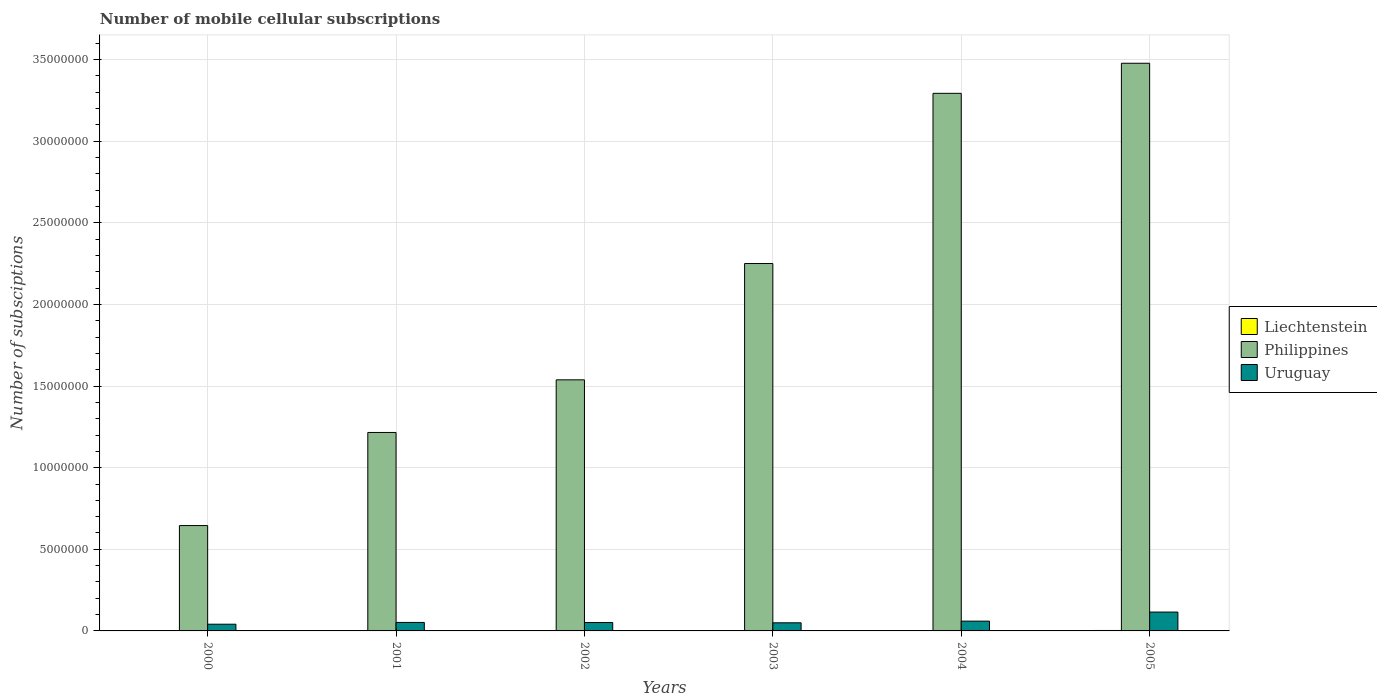Are the number of bars per tick equal to the number of legend labels?
Your answer should be very brief. Yes. Are the number of bars on each tick of the X-axis equal?
Provide a short and direct response. Yes. How many bars are there on the 3rd tick from the left?
Your response must be concise. 3. What is the label of the 6th group of bars from the left?
Keep it short and to the point. 2005. In how many cases, is the number of bars for a given year not equal to the number of legend labels?
Give a very brief answer. 0. What is the number of mobile cellular subscriptions in Uruguay in 2005?
Give a very brief answer. 1.15e+06. Across all years, what is the maximum number of mobile cellular subscriptions in Uruguay?
Give a very brief answer. 1.15e+06. Across all years, what is the minimum number of mobile cellular subscriptions in Uruguay?
Provide a succinct answer. 4.11e+05. In which year was the number of mobile cellular subscriptions in Liechtenstein minimum?
Give a very brief answer. 2000. What is the total number of mobile cellular subscriptions in Uruguay in the graph?
Offer a terse response. 3.70e+06. What is the difference between the number of mobile cellular subscriptions in Liechtenstein in 2000 and that in 2004?
Your answer should be very brief. -1.55e+04. What is the difference between the number of mobile cellular subscriptions in Philippines in 2000 and the number of mobile cellular subscriptions in Uruguay in 2004?
Make the answer very short. 5.85e+06. What is the average number of mobile cellular subscriptions in Uruguay per year?
Keep it short and to the point. 6.16e+05. In the year 2002, what is the difference between the number of mobile cellular subscriptions in Philippines and number of mobile cellular subscriptions in Liechtenstein?
Your response must be concise. 1.54e+07. What is the ratio of the number of mobile cellular subscriptions in Uruguay in 2001 to that in 2005?
Provide a short and direct response. 0.45. Is the difference between the number of mobile cellular subscriptions in Philippines in 2001 and 2004 greater than the difference between the number of mobile cellular subscriptions in Liechtenstein in 2001 and 2004?
Provide a short and direct response. No. What is the difference between the highest and the second highest number of mobile cellular subscriptions in Uruguay?
Provide a succinct answer. 5.55e+05. What is the difference between the highest and the lowest number of mobile cellular subscriptions in Uruguay?
Your answer should be very brief. 7.44e+05. In how many years, is the number of mobile cellular subscriptions in Uruguay greater than the average number of mobile cellular subscriptions in Uruguay taken over all years?
Your response must be concise. 1. What does the 3rd bar from the right in 2000 represents?
Keep it short and to the point. Liechtenstein. Is it the case that in every year, the sum of the number of mobile cellular subscriptions in Philippines and number of mobile cellular subscriptions in Liechtenstein is greater than the number of mobile cellular subscriptions in Uruguay?
Make the answer very short. Yes. How many bars are there?
Keep it short and to the point. 18. How many years are there in the graph?
Keep it short and to the point. 6. What is the difference between two consecutive major ticks on the Y-axis?
Provide a succinct answer. 5.00e+06. Does the graph contain any zero values?
Offer a terse response. No. How are the legend labels stacked?
Offer a terse response. Vertical. What is the title of the graph?
Offer a terse response. Number of mobile cellular subscriptions. Does "Sao Tome and Principe" appear as one of the legend labels in the graph?
Your answer should be compact. No. What is the label or title of the Y-axis?
Your answer should be compact. Number of subsciptions. What is the Number of subsciptions in Philippines in 2000?
Give a very brief answer. 6.45e+06. What is the Number of subsciptions in Uruguay in 2000?
Make the answer very short. 4.11e+05. What is the Number of subsciptions of Liechtenstein in 2001?
Make the answer very short. 1.10e+04. What is the Number of subsciptions of Philippines in 2001?
Provide a succinct answer. 1.22e+07. What is the Number of subsciptions in Uruguay in 2001?
Provide a short and direct response. 5.20e+05. What is the Number of subsciptions in Liechtenstein in 2002?
Provide a succinct answer. 1.14e+04. What is the Number of subsciptions of Philippines in 2002?
Ensure brevity in your answer.  1.54e+07. What is the Number of subsciptions of Uruguay in 2002?
Provide a short and direct response. 5.14e+05. What is the Number of subsciptions of Liechtenstein in 2003?
Your answer should be compact. 2.50e+04. What is the Number of subsciptions in Philippines in 2003?
Your answer should be very brief. 2.25e+07. What is the Number of subsciptions in Uruguay in 2003?
Your answer should be compact. 4.98e+05. What is the Number of subsciptions in Liechtenstein in 2004?
Provide a succinct answer. 2.55e+04. What is the Number of subsciptions in Philippines in 2004?
Offer a very short reply. 3.29e+07. What is the Number of subsciptions of Uruguay in 2004?
Make the answer very short. 6.00e+05. What is the Number of subsciptions of Liechtenstein in 2005?
Keep it short and to the point. 2.75e+04. What is the Number of subsciptions of Philippines in 2005?
Give a very brief answer. 3.48e+07. What is the Number of subsciptions of Uruguay in 2005?
Provide a short and direct response. 1.15e+06. Across all years, what is the maximum Number of subsciptions in Liechtenstein?
Provide a succinct answer. 2.75e+04. Across all years, what is the maximum Number of subsciptions in Philippines?
Offer a terse response. 3.48e+07. Across all years, what is the maximum Number of subsciptions in Uruguay?
Ensure brevity in your answer.  1.15e+06. Across all years, what is the minimum Number of subsciptions of Liechtenstein?
Your response must be concise. 10000. Across all years, what is the minimum Number of subsciptions of Philippines?
Your answer should be compact. 6.45e+06. Across all years, what is the minimum Number of subsciptions in Uruguay?
Provide a short and direct response. 4.11e+05. What is the total Number of subsciptions of Liechtenstein in the graph?
Your answer should be very brief. 1.10e+05. What is the total Number of subsciptions of Philippines in the graph?
Offer a terse response. 1.24e+08. What is the total Number of subsciptions of Uruguay in the graph?
Make the answer very short. 3.70e+06. What is the difference between the Number of subsciptions in Liechtenstein in 2000 and that in 2001?
Give a very brief answer. -1000. What is the difference between the Number of subsciptions of Philippines in 2000 and that in 2001?
Make the answer very short. -5.70e+06. What is the difference between the Number of subsciptions of Uruguay in 2000 and that in 2001?
Provide a short and direct response. -1.09e+05. What is the difference between the Number of subsciptions in Liechtenstein in 2000 and that in 2002?
Make the answer very short. -1402. What is the difference between the Number of subsciptions of Philippines in 2000 and that in 2002?
Give a very brief answer. -8.93e+06. What is the difference between the Number of subsciptions in Uruguay in 2000 and that in 2002?
Offer a very short reply. -1.03e+05. What is the difference between the Number of subsciptions in Liechtenstein in 2000 and that in 2003?
Make the answer very short. -1.50e+04. What is the difference between the Number of subsciptions of Philippines in 2000 and that in 2003?
Your response must be concise. -1.61e+07. What is the difference between the Number of subsciptions of Uruguay in 2000 and that in 2003?
Your response must be concise. -8.67e+04. What is the difference between the Number of subsciptions in Liechtenstein in 2000 and that in 2004?
Provide a succinct answer. -1.55e+04. What is the difference between the Number of subsciptions in Philippines in 2000 and that in 2004?
Give a very brief answer. -2.65e+07. What is the difference between the Number of subsciptions of Uruguay in 2000 and that in 2004?
Your answer should be very brief. -1.89e+05. What is the difference between the Number of subsciptions of Liechtenstein in 2000 and that in 2005?
Provide a short and direct response. -1.75e+04. What is the difference between the Number of subsciptions of Philippines in 2000 and that in 2005?
Keep it short and to the point. -2.83e+07. What is the difference between the Number of subsciptions in Uruguay in 2000 and that in 2005?
Provide a succinct answer. -7.44e+05. What is the difference between the Number of subsciptions in Liechtenstein in 2001 and that in 2002?
Ensure brevity in your answer.  -402. What is the difference between the Number of subsciptions of Philippines in 2001 and that in 2002?
Keep it short and to the point. -3.22e+06. What is the difference between the Number of subsciptions of Uruguay in 2001 and that in 2002?
Ensure brevity in your answer.  6463. What is the difference between the Number of subsciptions in Liechtenstein in 2001 and that in 2003?
Offer a terse response. -1.40e+04. What is the difference between the Number of subsciptions of Philippines in 2001 and that in 2003?
Your answer should be very brief. -1.04e+07. What is the difference between the Number of subsciptions in Uruguay in 2001 and that in 2003?
Provide a succinct answer. 2.25e+04. What is the difference between the Number of subsciptions in Liechtenstein in 2001 and that in 2004?
Your response must be concise. -1.45e+04. What is the difference between the Number of subsciptions of Philippines in 2001 and that in 2004?
Your answer should be compact. -2.08e+07. What is the difference between the Number of subsciptions in Uruguay in 2001 and that in 2004?
Your answer should be very brief. -7.98e+04. What is the difference between the Number of subsciptions of Liechtenstein in 2001 and that in 2005?
Offer a very short reply. -1.65e+04. What is the difference between the Number of subsciptions of Philippines in 2001 and that in 2005?
Give a very brief answer. -2.26e+07. What is the difference between the Number of subsciptions of Uruguay in 2001 and that in 2005?
Offer a very short reply. -6.35e+05. What is the difference between the Number of subsciptions of Liechtenstein in 2002 and that in 2003?
Ensure brevity in your answer.  -1.36e+04. What is the difference between the Number of subsciptions in Philippines in 2002 and that in 2003?
Ensure brevity in your answer.  -7.13e+06. What is the difference between the Number of subsciptions in Uruguay in 2002 and that in 2003?
Provide a succinct answer. 1.60e+04. What is the difference between the Number of subsciptions in Liechtenstein in 2002 and that in 2004?
Keep it short and to the point. -1.41e+04. What is the difference between the Number of subsciptions of Philippines in 2002 and that in 2004?
Offer a terse response. -1.76e+07. What is the difference between the Number of subsciptions of Uruguay in 2002 and that in 2004?
Your answer should be compact. -8.62e+04. What is the difference between the Number of subsciptions in Liechtenstein in 2002 and that in 2005?
Make the answer very short. -1.61e+04. What is the difference between the Number of subsciptions in Philippines in 2002 and that in 2005?
Make the answer very short. -1.94e+07. What is the difference between the Number of subsciptions in Uruguay in 2002 and that in 2005?
Provide a succinct answer. -6.41e+05. What is the difference between the Number of subsciptions of Liechtenstein in 2003 and that in 2004?
Provide a short and direct response. -500. What is the difference between the Number of subsciptions of Philippines in 2003 and that in 2004?
Make the answer very short. -1.04e+07. What is the difference between the Number of subsciptions of Uruguay in 2003 and that in 2004?
Provide a short and direct response. -1.02e+05. What is the difference between the Number of subsciptions in Liechtenstein in 2003 and that in 2005?
Your response must be concise. -2503. What is the difference between the Number of subsciptions of Philippines in 2003 and that in 2005?
Your answer should be compact. -1.23e+07. What is the difference between the Number of subsciptions in Uruguay in 2003 and that in 2005?
Your response must be concise. -6.57e+05. What is the difference between the Number of subsciptions of Liechtenstein in 2004 and that in 2005?
Give a very brief answer. -2003. What is the difference between the Number of subsciptions of Philippines in 2004 and that in 2005?
Ensure brevity in your answer.  -1.84e+06. What is the difference between the Number of subsciptions in Uruguay in 2004 and that in 2005?
Make the answer very short. -5.55e+05. What is the difference between the Number of subsciptions of Liechtenstein in 2000 and the Number of subsciptions of Philippines in 2001?
Offer a very short reply. -1.21e+07. What is the difference between the Number of subsciptions in Liechtenstein in 2000 and the Number of subsciptions in Uruguay in 2001?
Make the answer very short. -5.10e+05. What is the difference between the Number of subsciptions in Philippines in 2000 and the Number of subsciptions in Uruguay in 2001?
Make the answer very short. 5.93e+06. What is the difference between the Number of subsciptions in Liechtenstein in 2000 and the Number of subsciptions in Philippines in 2002?
Offer a terse response. -1.54e+07. What is the difference between the Number of subsciptions in Liechtenstein in 2000 and the Number of subsciptions in Uruguay in 2002?
Your answer should be very brief. -5.04e+05. What is the difference between the Number of subsciptions of Philippines in 2000 and the Number of subsciptions of Uruguay in 2002?
Ensure brevity in your answer.  5.94e+06. What is the difference between the Number of subsciptions of Liechtenstein in 2000 and the Number of subsciptions of Philippines in 2003?
Offer a terse response. -2.25e+07. What is the difference between the Number of subsciptions of Liechtenstein in 2000 and the Number of subsciptions of Uruguay in 2003?
Provide a succinct answer. -4.88e+05. What is the difference between the Number of subsciptions in Philippines in 2000 and the Number of subsciptions in Uruguay in 2003?
Keep it short and to the point. 5.96e+06. What is the difference between the Number of subsciptions of Liechtenstein in 2000 and the Number of subsciptions of Philippines in 2004?
Your answer should be compact. -3.29e+07. What is the difference between the Number of subsciptions in Liechtenstein in 2000 and the Number of subsciptions in Uruguay in 2004?
Ensure brevity in your answer.  -5.90e+05. What is the difference between the Number of subsciptions in Philippines in 2000 and the Number of subsciptions in Uruguay in 2004?
Keep it short and to the point. 5.85e+06. What is the difference between the Number of subsciptions in Liechtenstein in 2000 and the Number of subsciptions in Philippines in 2005?
Ensure brevity in your answer.  -3.48e+07. What is the difference between the Number of subsciptions of Liechtenstein in 2000 and the Number of subsciptions of Uruguay in 2005?
Offer a terse response. -1.14e+06. What is the difference between the Number of subsciptions of Philippines in 2000 and the Number of subsciptions of Uruguay in 2005?
Your answer should be compact. 5.30e+06. What is the difference between the Number of subsciptions in Liechtenstein in 2001 and the Number of subsciptions in Philippines in 2002?
Your answer should be compact. -1.54e+07. What is the difference between the Number of subsciptions in Liechtenstein in 2001 and the Number of subsciptions in Uruguay in 2002?
Your answer should be compact. -5.03e+05. What is the difference between the Number of subsciptions of Philippines in 2001 and the Number of subsciptions of Uruguay in 2002?
Your answer should be very brief. 1.16e+07. What is the difference between the Number of subsciptions of Liechtenstein in 2001 and the Number of subsciptions of Philippines in 2003?
Provide a short and direct response. -2.25e+07. What is the difference between the Number of subsciptions of Liechtenstein in 2001 and the Number of subsciptions of Uruguay in 2003?
Offer a terse response. -4.87e+05. What is the difference between the Number of subsciptions in Philippines in 2001 and the Number of subsciptions in Uruguay in 2003?
Ensure brevity in your answer.  1.17e+07. What is the difference between the Number of subsciptions of Liechtenstein in 2001 and the Number of subsciptions of Philippines in 2004?
Provide a succinct answer. -3.29e+07. What is the difference between the Number of subsciptions of Liechtenstein in 2001 and the Number of subsciptions of Uruguay in 2004?
Offer a very short reply. -5.89e+05. What is the difference between the Number of subsciptions of Philippines in 2001 and the Number of subsciptions of Uruguay in 2004?
Your response must be concise. 1.16e+07. What is the difference between the Number of subsciptions of Liechtenstein in 2001 and the Number of subsciptions of Philippines in 2005?
Make the answer very short. -3.48e+07. What is the difference between the Number of subsciptions in Liechtenstein in 2001 and the Number of subsciptions in Uruguay in 2005?
Offer a very short reply. -1.14e+06. What is the difference between the Number of subsciptions of Philippines in 2001 and the Number of subsciptions of Uruguay in 2005?
Your answer should be very brief. 1.10e+07. What is the difference between the Number of subsciptions in Liechtenstein in 2002 and the Number of subsciptions in Philippines in 2003?
Ensure brevity in your answer.  -2.25e+07. What is the difference between the Number of subsciptions of Liechtenstein in 2002 and the Number of subsciptions of Uruguay in 2003?
Make the answer very short. -4.86e+05. What is the difference between the Number of subsciptions in Philippines in 2002 and the Number of subsciptions in Uruguay in 2003?
Give a very brief answer. 1.49e+07. What is the difference between the Number of subsciptions in Liechtenstein in 2002 and the Number of subsciptions in Philippines in 2004?
Your answer should be very brief. -3.29e+07. What is the difference between the Number of subsciptions in Liechtenstein in 2002 and the Number of subsciptions in Uruguay in 2004?
Give a very brief answer. -5.88e+05. What is the difference between the Number of subsciptions in Philippines in 2002 and the Number of subsciptions in Uruguay in 2004?
Offer a very short reply. 1.48e+07. What is the difference between the Number of subsciptions of Liechtenstein in 2002 and the Number of subsciptions of Philippines in 2005?
Offer a terse response. -3.48e+07. What is the difference between the Number of subsciptions in Liechtenstein in 2002 and the Number of subsciptions in Uruguay in 2005?
Offer a terse response. -1.14e+06. What is the difference between the Number of subsciptions in Philippines in 2002 and the Number of subsciptions in Uruguay in 2005?
Offer a terse response. 1.42e+07. What is the difference between the Number of subsciptions of Liechtenstein in 2003 and the Number of subsciptions of Philippines in 2004?
Provide a short and direct response. -3.29e+07. What is the difference between the Number of subsciptions of Liechtenstein in 2003 and the Number of subsciptions of Uruguay in 2004?
Give a very brief answer. -5.75e+05. What is the difference between the Number of subsciptions of Philippines in 2003 and the Number of subsciptions of Uruguay in 2004?
Offer a very short reply. 2.19e+07. What is the difference between the Number of subsciptions in Liechtenstein in 2003 and the Number of subsciptions in Philippines in 2005?
Ensure brevity in your answer.  -3.48e+07. What is the difference between the Number of subsciptions in Liechtenstein in 2003 and the Number of subsciptions in Uruguay in 2005?
Your answer should be very brief. -1.13e+06. What is the difference between the Number of subsciptions of Philippines in 2003 and the Number of subsciptions of Uruguay in 2005?
Keep it short and to the point. 2.14e+07. What is the difference between the Number of subsciptions in Liechtenstein in 2004 and the Number of subsciptions in Philippines in 2005?
Offer a terse response. -3.48e+07. What is the difference between the Number of subsciptions of Liechtenstein in 2004 and the Number of subsciptions of Uruguay in 2005?
Give a very brief answer. -1.13e+06. What is the difference between the Number of subsciptions of Philippines in 2004 and the Number of subsciptions of Uruguay in 2005?
Keep it short and to the point. 3.18e+07. What is the average Number of subsciptions in Liechtenstein per year?
Ensure brevity in your answer.  1.84e+04. What is the average Number of subsciptions of Philippines per year?
Keep it short and to the point. 2.07e+07. What is the average Number of subsciptions of Uruguay per year?
Give a very brief answer. 6.16e+05. In the year 2000, what is the difference between the Number of subsciptions of Liechtenstein and Number of subsciptions of Philippines?
Make the answer very short. -6.44e+06. In the year 2000, what is the difference between the Number of subsciptions of Liechtenstein and Number of subsciptions of Uruguay?
Make the answer very short. -4.01e+05. In the year 2000, what is the difference between the Number of subsciptions of Philippines and Number of subsciptions of Uruguay?
Provide a short and direct response. 6.04e+06. In the year 2001, what is the difference between the Number of subsciptions in Liechtenstein and Number of subsciptions in Philippines?
Provide a short and direct response. -1.21e+07. In the year 2001, what is the difference between the Number of subsciptions in Liechtenstein and Number of subsciptions in Uruguay?
Offer a terse response. -5.09e+05. In the year 2001, what is the difference between the Number of subsciptions in Philippines and Number of subsciptions in Uruguay?
Keep it short and to the point. 1.16e+07. In the year 2002, what is the difference between the Number of subsciptions in Liechtenstein and Number of subsciptions in Philippines?
Your answer should be compact. -1.54e+07. In the year 2002, what is the difference between the Number of subsciptions of Liechtenstein and Number of subsciptions of Uruguay?
Provide a short and direct response. -5.02e+05. In the year 2002, what is the difference between the Number of subsciptions in Philippines and Number of subsciptions in Uruguay?
Your answer should be compact. 1.49e+07. In the year 2003, what is the difference between the Number of subsciptions in Liechtenstein and Number of subsciptions in Philippines?
Give a very brief answer. -2.25e+07. In the year 2003, what is the difference between the Number of subsciptions in Liechtenstein and Number of subsciptions in Uruguay?
Give a very brief answer. -4.73e+05. In the year 2003, what is the difference between the Number of subsciptions of Philippines and Number of subsciptions of Uruguay?
Offer a very short reply. 2.20e+07. In the year 2004, what is the difference between the Number of subsciptions in Liechtenstein and Number of subsciptions in Philippines?
Ensure brevity in your answer.  -3.29e+07. In the year 2004, what is the difference between the Number of subsciptions of Liechtenstein and Number of subsciptions of Uruguay?
Offer a terse response. -5.74e+05. In the year 2004, what is the difference between the Number of subsciptions in Philippines and Number of subsciptions in Uruguay?
Make the answer very short. 3.23e+07. In the year 2005, what is the difference between the Number of subsciptions in Liechtenstein and Number of subsciptions in Philippines?
Offer a terse response. -3.48e+07. In the year 2005, what is the difference between the Number of subsciptions of Liechtenstein and Number of subsciptions of Uruguay?
Ensure brevity in your answer.  -1.13e+06. In the year 2005, what is the difference between the Number of subsciptions in Philippines and Number of subsciptions in Uruguay?
Your response must be concise. 3.36e+07. What is the ratio of the Number of subsciptions of Liechtenstein in 2000 to that in 2001?
Your response must be concise. 0.91. What is the ratio of the Number of subsciptions in Philippines in 2000 to that in 2001?
Make the answer very short. 0.53. What is the ratio of the Number of subsciptions of Uruguay in 2000 to that in 2001?
Give a very brief answer. 0.79. What is the ratio of the Number of subsciptions of Liechtenstein in 2000 to that in 2002?
Ensure brevity in your answer.  0.88. What is the ratio of the Number of subsciptions in Philippines in 2000 to that in 2002?
Make the answer very short. 0.42. What is the ratio of the Number of subsciptions of Uruguay in 2000 to that in 2002?
Give a very brief answer. 0.8. What is the ratio of the Number of subsciptions in Liechtenstein in 2000 to that in 2003?
Your answer should be compact. 0.4. What is the ratio of the Number of subsciptions of Philippines in 2000 to that in 2003?
Your response must be concise. 0.29. What is the ratio of the Number of subsciptions in Uruguay in 2000 to that in 2003?
Make the answer very short. 0.83. What is the ratio of the Number of subsciptions of Liechtenstein in 2000 to that in 2004?
Provide a succinct answer. 0.39. What is the ratio of the Number of subsciptions in Philippines in 2000 to that in 2004?
Your answer should be compact. 0.2. What is the ratio of the Number of subsciptions in Uruguay in 2000 to that in 2004?
Your answer should be compact. 0.68. What is the ratio of the Number of subsciptions in Liechtenstein in 2000 to that in 2005?
Make the answer very short. 0.36. What is the ratio of the Number of subsciptions of Philippines in 2000 to that in 2005?
Offer a very short reply. 0.19. What is the ratio of the Number of subsciptions in Uruguay in 2000 to that in 2005?
Give a very brief answer. 0.36. What is the ratio of the Number of subsciptions in Liechtenstein in 2001 to that in 2002?
Give a very brief answer. 0.96. What is the ratio of the Number of subsciptions in Philippines in 2001 to that in 2002?
Your response must be concise. 0.79. What is the ratio of the Number of subsciptions in Uruguay in 2001 to that in 2002?
Give a very brief answer. 1.01. What is the ratio of the Number of subsciptions of Liechtenstein in 2001 to that in 2003?
Offer a very short reply. 0.44. What is the ratio of the Number of subsciptions of Philippines in 2001 to that in 2003?
Offer a very short reply. 0.54. What is the ratio of the Number of subsciptions of Uruguay in 2001 to that in 2003?
Your answer should be very brief. 1.05. What is the ratio of the Number of subsciptions of Liechtenstein in 2001 to that in 2004?
Offer a very short reply. 0.43. What is the ratio of the Number of subsciptions in Philippines in 2001 to that in 2004?
Provide a succinct answer. 0.37. What is the ratio of the Number of subsciptions of Uruguay in 2001 to that in 2004?
Keep it short and to the point. 0.87. What is the ratio of the Number of subsciptions of Philippines in 2001 to that in 2005?
Your response must be concise. 0.35. What is the ratio of the Number of subsciptions of Uruguay in 2001 to that in 2005?
Keep it short and to the point. 0.45. What is the ratio of the Number of subsciptions of Liechtenstein in 2002 to that in 2003?
Your answer should be compact. 0.46. What is the ratio of the Number of subsciptions of Philippines in 2002 to that in 2003?
Offer a very short reply. 0.68. What is the ratio of the Number of subsciptions of Uruguay in 2002 to that in 2003?
Keep it short and to the point. 1.03. What is the ratio of the Number of subsciptions in Liechtenstein in 2002 to that in 2004?
Your response must be concise. 0.45. What is the ratio of the Number of subsciptions of Philippines in 2002 to that in 2004?
Give a very brief answer. 0.47. What is the ratio of the Number of subsciptions of Uruguay in 2002 to that in 2004?
Your answer should be compact. 0.86. What is the ratio of the Number of subsciptions in Liechtenstein in 2002 to that in 2005?
Your answer should be compact. 0.41. What is the ratio of the Number of subsciptions in Philippines in 2002 to that in 2005?
Offer a terse response. 0.44. What is the ratio of the Number of subsciptions in Uruguay in 2002 to that in 2005?
Your response must be concise. 0.44. What is the ratio of the Number of subsciptions of Liechtenstein in 2003 to that in 2004?
Offer a terse response. 0.98. What is the ratio of the Number of subsciptions in Philippines in 2003 to that in 2004?
Keep it short and to the point. 0.68. What is the ratio of the Number of subsciptions of Uruguay in 2003 to that in 2004?
Your response must be concise. 0.83. What is the ratio of the Number of subsciptions in Liechtenstein in 2003 to that in 2005?
Provide a succinct answer. 0.91. What is the ratio of the Number of subsciptions in Philippines in 2003 to that in 2005?
Offer a very short reply. 0.65. What is the ratio of the Number of subsciptions in Uruguay in 2003 to that in 2005?
Your answer should be compact. 0.43. What is the ratio of the Number of subsciptions of Liechtenstein in 2004 to that in 2005?
Your answer should be very brief. 0.93. What is the ratio of the Number of subsciptions of Philippines in 2004 to that in 2005?
Provide a short and direct response. 0.95. What is the ratio of the Number of subsciptions in Uruguay in 2004 to that in 2005?
Offer a very short reply. 0.52. What is the difference between the highest and the second highest Number of subsciptions in Liechtenstein?
Provide a short and direct response. 2003. What is the difference between the highest and the second highest Number of subsciptions of Philippines?
Ensure brevity in your answer.  1.84e+06. What is the difference between the highest and the second highest Number of subsciptions in Uruguay?
Give a very brief answer. 5.55e+05. What is the difference between the highest and the lowest Number of subsciptions in Liechtenstein?
Ensure brevity in your answer.  1.75e+04. What is the difference between the highest and the lowest Number of subsciptions of Philippines?
Ensure brevity in your answer.  2.83e+07. What is the difference between the highest and the lowest Number of subsciptions of Uruguay?
Ensure brevity in your answer.  7.44e+05. 